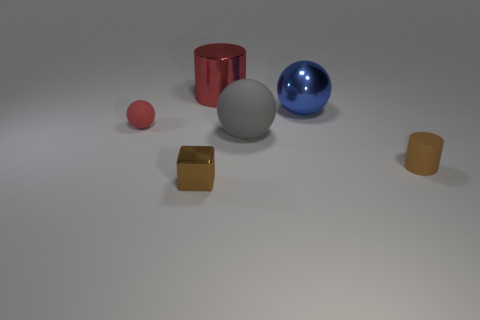Add 1 big purple rubber balls. How many objects exist? 7 Subtract all cylinders. How many objects are left? 4 Add 3 tiny red blocks. How many tiny red blocks exist? 3 Subtract 0 gray blocks. How many objects are left? 6 Subtract all tiny green metallic cylinders. Subtract all big red cylinders. How many objects are left? 5 Add 3 gray things. How many gray things are left? 4 